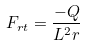Convert formula to latex. <formula><loc_0><loc_0><loc_500><loc_500>F _ { r t } = \frac { - Q } { L ^ { 2 } r }</formula> 